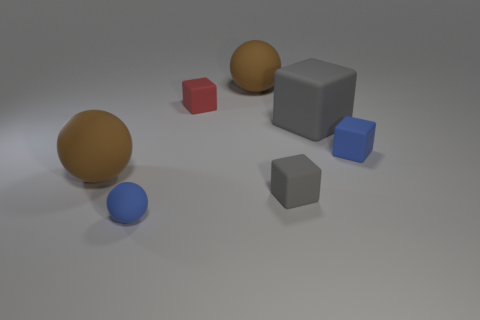Add 2 blue balls. How many objects exist? 9 Subtract all blocks. How many objects are left? 3 Add 5 large brown balls. How many large brown balls exist? 7 Subtract 0 yellow balls. How many objects are left? 7 Subtract all blue balls. Subtract all small blue rubber objects. How many objects are left? 4 Add 2 blue spheres. How many blue spheres are left? 3 